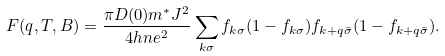Convert formula to latex. <formula><loc_0><loc_0><loc_500><loc_500>F ( q , T , B ) = \frac { \pi D ( 0 ) m ^ { * } J ^ { 2 } } { 4 h n e ^ { 2 } } \sum _ { k \sigma } f _ { k \sigma } ( 1 - f _ { k \sigma } ) f _ { k + q \bar { \sigma } } ( 1 - f _ { k + q \bar { \sigma } } ) .</formula> 